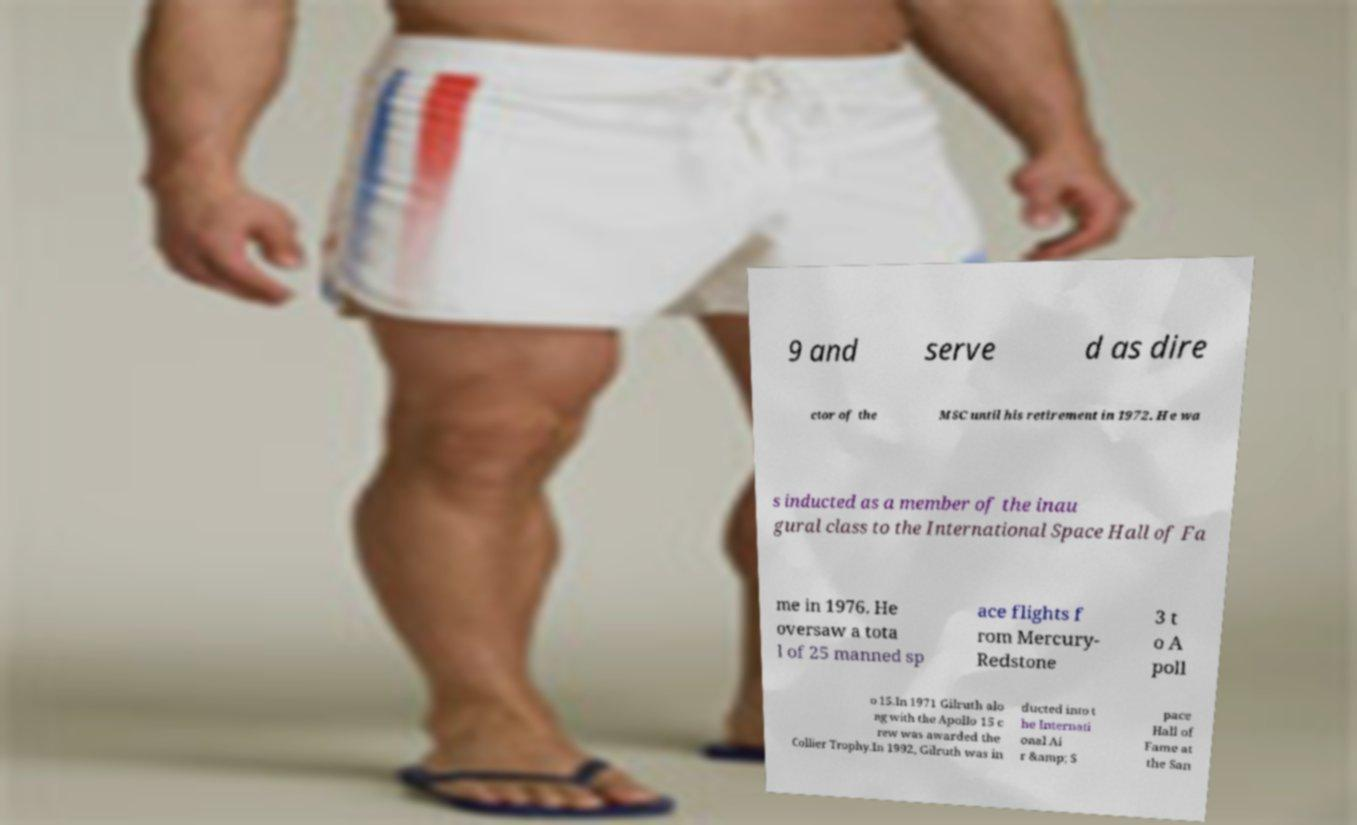There's text embedded in this image that I need extracted. Can you transcribe it verbatim? 9 and serve d as dire ctor of the MSC until his retirement in 1972. He wa s inducted as a member of the inau gural class to the International Space Hall of Fa me in 1976. He oversaw a tota l of 25 manned sp ace flights f rom Mercury- Redstone 3 t o A poll o 15.In 1971 Gilruth alo ng with the Apollo 15 c rew was awarded the Collier Trophy.In 1992, Gilruth was in ducted into t he Internati onal Ai r &amp; S pace Hall of Fame at the San 